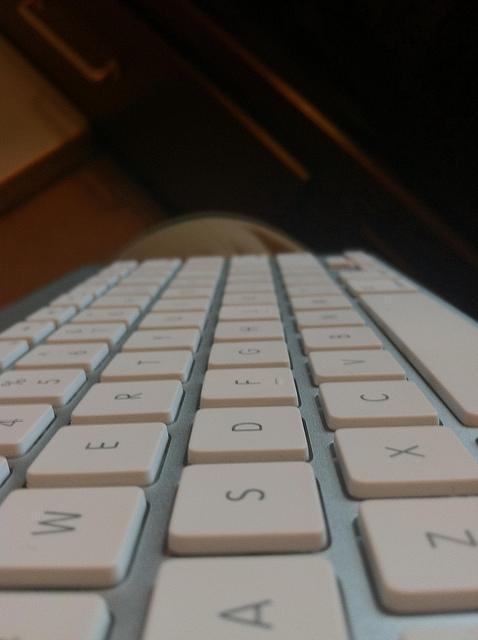How many keyboards are there?
Give a very brief answer. 1. 